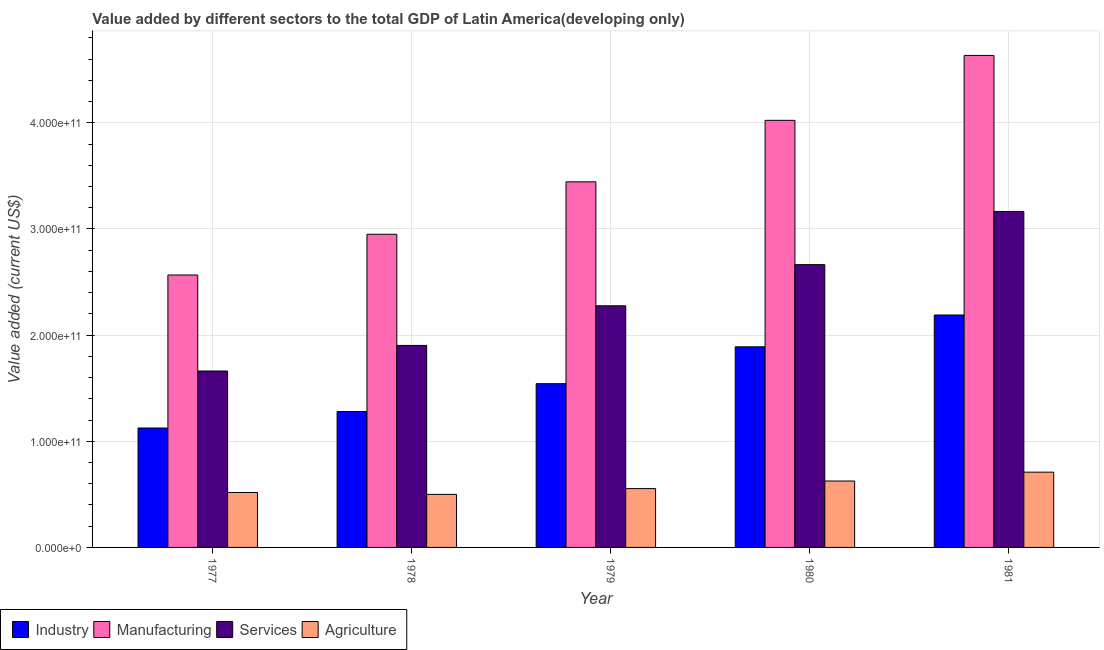How many groups of bars are there?
Give a very brief answer. 5. Are the number of bars per tick equal to the number of legend labels?
Provide a short and direct response. Yes. How many bars are there on the 2nd tick from the left?
Provide a short and direct response. 4. How many bars are there on the 5th tick from the right?
Your answer should be very brief. 4. What is the value added by agricultural sector in 1979?
Offer a terse response. 5.54e+1. Across all years, what is the maximum value added by manufacturing sector?
Keep it short and to the point. 4.63e+11. Across all years, what is the minimum value added by agricultural sector?
Your answer should be compact. 5.00e+1. In which year was the value added by services sector maximum?
Offer a very short reply. 1981. What is the total value added by agricultural sector in the graph?
Make the answer very short. 2.91e+11. What is the difference between the value added by manufacturing sector in 1977 and that in 1980?
Offer a terse response. -1.46e+11. What is the difference between the value added by services sector in 1979 and the value added by manufacturing sector in 1981?
Provide a succinct answer. -8.89e+1. What is the average value added by industrial sector per year?
Keep it short and to the point. 1.61e+11. What is the ratio of the value added by manufacturing sector in 1978 to that in 1979?
Your response must be concise. 0.86. What is the difference between the highest and the second highest value added by manufacturing sector?
Your response must be concise. 6.11e+1. What is the difference between the highest and the lowest value added by industrial sector?
Give a very brief answer. 1.06e+11. In how many years, is the value added by services sector greater than the average value added by services sector taken over all years?
Offer a terse response. 2. Is the sum of the value added by agricultural sector in 1977 and 1978 greater than the maximum value added by services sector across all years?
Make the answer very short. Yes. What does the 4th bar from the left in 1979 represents?
Your answer should be compact. Agriculture. What does the 4th bar from the right in 1979 represents?
Provide a succinct answer. Industry. Is it the case that in every year, the sum of the value added by industrial sector and value added by manufacturing sector is greater than the value added by services sector?
Your response must be concise. Yes. How many bars are there?
Your response must be concise. 20. What is the difference between two consecutive major ticks on the Y-axis?
Your answer should be compact. 1.00e+11. Are the values on the major ticks of Y-axis written in scientific E-notation?
Give a very brief answer. Yes. How many legend labels are there?
Your answer should be very brief. 4. How are the legend labels stacked?
Your answer should be compact. Horizontal. What is the title of the graph?
Ensure brevity in your answer.  Value added by different sectors to the total GDP of Latin America(developing only). What is the label or title of the X-axis?
Make the answer very short. Year. What is the label or title of the Y-axis?
Offer a very short reply. Value added (current US$). What is the Value added (current US$) of Industry in 1977?
Provide a short and direct response. 1.13e+11. What is the Value added (current US$) in Manufacturing in 1977?
Keep it short and to the point. 2.57e+11. What is the Value added (current US$) of Services in 1977?
Keep it short and to the point. 1.66e+11. What is the Value added (current US$) of Agriculture in 1977?
Provide a short and direct response. 5.17e+1. What is the Value added (current US$) of Industry in 1978?
Keep it short and to the point. 1.28e+11. What is the Value added (current US$) of Manufacturing in 1978?
Your answer should be very brief. 2.95e+11. What is the Value added (current US$) of Services in 1978?
Offer a terse response. 1.90e+11. What is the Value added (current US$) in Agriculture in 1978?
Offer a terse response. 5.00e+1. What is the Value added (current US$) of Industry in 1979?
Provide a succinct answer. 1.54e+11. What is the Value added (current US$) in Manufacturing in 1979?
Make the answer very short. 3.44e+11. What is the Value added (current US$) of Services in 1979?
Give a very brief answer. 2.28e+11. What is the Value added (current US$) in Agriculture in 1979?
Ensure brevity in your answer.  5.54e+1. What is the Value added (current US$) in Industry in 1980?
Your answer should be compact. 1.89e+11. What is the Value added (current US$) in Manufacturing in 1980?
Keep it short and to the point. 4.02e+11. What is the Value added (current US$) in Services in 1980?
Your answer should be compact. 2.66e+11. What is the Value added (current US$) in Agriculture in 1980?
Provide a succinct answer. 6.26e+1. What is the Value added (current US$) in Industry in 1981?
Offer a very short reply. 2.19e+11. What is the Value added (current US$) of Manufacturing in 1981?
Ensure brevity in your answer.  4.63e+11. What is the Value added (current US$) in Services in 1981?
Provide a succinct answer. 3.17e+11. What is the Value added (current US$) in Agriculture in 1981?
Provide a succinct answer. 7.09e+1. Across all years, what is the maximum Value added (current US$) of Industry?
Your response must be concise. 2.19e+11. Across all years, what is the maximum Value added (current US$) of Manufacturing?
Offer a very short reply. 4.63e+11. Across all years, what is the maximum Value added (current US$) in Services?
Ensure brevity in your answer.  3.17e+11. Across all years, what is the maximum Value added (current US$) in Agriculture?
Give a very brief answer. 7.09e+1. Across all years, what is the minimum Value added (current US$) of Industry?
Provide a short and direct response. 1.13e+11. Across all years, what is the minimum Value added (current US$) of Manufacturing?
Provide a short and direct response. 2.57e+11. Across all years, what is the minimum Value added (current US$) of Services?
Offer a very short reply. 1.66e+11. Across all years, what is the minimum Value added (current US$) in Agriculture?
Offer a very short reply. 5.00e+1. What is the total Value added (current US$) of Industry in the graph?
Your answer should be very brief. 8.03e+11. What is the total Value added (current US$) of Manufacturing in the graph?
Keep it short and to the point. 1.76e+12. What is the total Value added (current US$) of Services in the graph?
Keep it short and to the point. 1.17e+12. What is the total Value added (current US$) in Agriculture in the graph?
Give a very brief answer. 2.91e+11. What is the difference between the Value added (current US$) in Industry in 1977 and that in 1978?
Offer a very short reply. -1.55e+1. What is the difference between the Value added (current US$) in Manufacturing in 1977 and that in 1978?
Your answer should be very brief. -3.84e+1. What is the difference between the Value added (current US$) of Services in 1977 and that in 1978?
Make the answer very short. -2.41e+1. What is the difference between the Value added (current US$) in Agriculture in 1977 and that in 1978?
Ensure brevity in your answer.  1.76e+09. What is the difference between the Value added (current US$) of Industry in 1977 and that in 1979?
Your answer should be very brief. -4.18e+1. What is the difference between the Value added (current US$) of Manufacturing in 1977 and that in 1979?
Offer a terse response. -8.78e+1. What is the difference between the Value added (current US$) of Services in 1977 and that in 1979?
Make the answer very short. -6.14e+1. What is the difference between the Value added (current US$) of Agriculture in 1977 and that in 1979?
Ensure brevity in your answer.  -3.68e+09. What is the difference between the Value added (current US$) of Industry in 1977 and that in 1980?
Provide a succinct answer. -7.65e+1. What is the difference between the Value added (current US$) of Manufacturing in 1977 and that in 1980?
Provide a short and direct response. -1.46e+11. What is the difference between the Value added (current US$) in Services in 1977 and that in 1980?
Offer a terse response. -1.00e+11. What is the difference between the Value added (current US$) in Agriculture in 1977 and that in 1980?
Provide a succinct answer. -1.08e+1. What is the difference between the Value added (current US$) in Industry in 1977 and that in 1981?
Provide a succinct answer. -1.06e+11. What is the difference between the Value added (current US$) of Manufacturing in 1977 and that in 1981?
Provide a short and direct response. -2.07e+11. What is the difference between the Value added (current US$) in Services in 1977 and that in 1981?
Offer a very short reply. -1.50e+11. What is the difference between the Value added (current US$) of Agriculture in 1977 and that in 1981?
Provide a short and direct response. -1.92e+1. What is the difference between the Value added (current US$) of Industry in 1978 and that in 1979?
Ensure brevity in your answer.  -2.62e+1. What is the difference between the Value added (current US$) in Manufacturing in 1978 and that in 1979?
Give a very brief answer. -4.94e+1. What is the difference between the Value added (current US$) of Services in 1978 and that in 1979?
Give a very brief answer. -3.73e+1. What is the difference between the Value added (current US$) of Agriculture in 1978 and that in 1979?
Make the answer very short. -5.45e+09. What is the difference between the Value added (current US$) in Industry in 1978 and that in 1980?
Keep it short and to the point. -6.10e+1. What is the difference between the Value added (current US$) in Manufacturing in 1978 and that in 1980?
Your response must be concise. -1.07e+11. What is the difference between the Value added (current US$) in Services in 1978 and that in 1980?
Your answer should be very brief. -7.61e+1. What is the difference between the Value added (current US$) of Agriculture in 1978 and that in 1980?
Ensure brevity in your answer.  -1.26e+1. What is the difference between the Value added (current US$) in Industry in 1978 and that in 1981?
Ensure brevity in your answer.  -9.09e+1. What is the difference between the Value added (current US$) of Manufacturing in 1978 and that in 1981?
Provide a succinct answer. -1.68e+11. What is the difference between the Value added (current US$) in Services in 1978 and that in 1981?
Ensure brevity in your answer.  -1.26e+11. What is the difference between the Value added (current US$) of Agriculture in 1978 and that in 1981?
Offer a very short reply. -2.09e+1. What is the difference between the Value added (current US$) of Industry in 1979 and that in 1980?
Offer a terse response. -3.47e+1. What is the difference between the Value added (current US$) of Manufacturing in 1979 and that in 1980?
Offer a terse response. -5.79e+1. What is the difference between the Value added (current US$) in Services in 1979 and that in 1980?
Your answer should be very brief. -3.88e+1. What is the difference between the Value added (current US$) in Agriculture in 1979 and that in 1980?
Offer a very short reply. -7.13e+09. What is the difference between the Value added (current US$) in Industry in 1979 and that in 1981?
Offer a terse response. -6.47e+1. What is the difference between the Value added (current US$) in Manufacturing in 1979 and that in 1981?
Provide a succinct answer. -1.19e+11. What is the difference between the Value added (current US$) in Services in 1979 and that in 1981?
Provide a succinct answer. -8.89e+1. What is the difference between the Value added (current US$) in Agriculture in 1979 and that in 1981?
Keep it short and to the point. -1.55e+1. What is the difference between the Value added (current US$) of Industry in 1980 and that in 1981?
Provide a succinct answer. -3.00e+1. What is the difference between the Value added (current US$) in Manufacturing in 1980 and that in 1981?
Make the answer very short. -6.11e+1. What is the difference between the Value added (current US$) of Services in 1980 and that in 1981?
Provide a short and direct response. -5.01e+1. What is the difference between the Value added (current US$) of Agriculture in 1980 and that in 1981?
Your answer should be compact. -8.35e+09. What is the difference between the Value added (current US$) of Industry in 1977 and the Value added (current US$) of Manufacturing in 1978?
Keep it short and to the point. -1.83e+11. What is the difference between the Value added (current US$) of Industry in 1977 and the Value added (current US$) of Services in 1978?
Your answer should be compact. -7.78e+1. What is the difference between the Value added (current US$) in Industry in 1977 and the Value added (current US$) in Agriculture in 1978?
Provide a succinct answer. 6.25e+1. What is the difference between the Value added (current US$) in Manufacturing in 1977 and the Value added (current US$) in Services in 1978?
Provide a short and direct response. 6.63e+1. What is the difference between the Value added (current US$) of Manufacturing in 1977 and the Value added (current US$) of Agriculture in 1978?
Offer a terse response. 2.07e+11. What is the difference between the Value added (current US$) in Services in 1977 and the Value added (current US$) in Agriculture in 1978?
Make the answer very short. 1.16e+11. What is the difference between the Value added (current US$) in Industry in 1977 and the Value added (current US$) in Manufacturing in 1979?
Your answer should be very brief. -2.32e+11. What is the difference between the Value added (current US$) in Industry in 1977 and the Value added (current US$) in Services in 1979?
Offer a very short reply. -1.15e+11. What is the difference between the Value added (current US$) in Industry in 1977 and the Value added (current US$) in Agriculture in 1979?
Make the answer very short. 5.71e+1. What is the difference between the Value added (current US$) in Manufacturing in 1977 and the Value added (current US$) in Services in 1979?
Give a very brief answer. 2.90e+1. What is the difference between the Value added (current US$) in Manufacturing in 1977 and the Value added (current US$) in Agriculture in 1979?
Ensure brevity in your answer.  2.01e+11. What is the difference between the Value added (current US$) in Services in 1977 and the Value added (current US$) in Agriculture in 1979?
Offer a very short reply. 1.11e+11. What is the difference between the Value added (current US$) of Industry in 1977 and the Value added (current US$) of Manufacturing in 1980?
Provide a succinct answer. -2.90e+11. What is the difference between the Value added (current US$) of Industry in 1977 and the Value added (current US$) of Services in 1980?
Your response must be concise. -1.54e+11. What is the difference between the Value added (current US$) of Industry in 1977 and the Value added (current US$) of Agriculture in 1980?
Offer a very short reply. 4.99e+1. What is the difference between the Value added (current US$) in Manufacturing in 1977 and the Value added (current US$) in Services in 1980?
Your response must be concise. -9.77e+09. What is the difference between the Value added (current US$) in Manufacturing in 1977 and the Value added (current US$) in Agriculture in 1980?
Give a very brief answer. 1.94e+11. What is the difference between the Value added (current US$) in Services in 1977 and the Value added (current US$) in Agriculture in 1980?
Keep it short and to the point. 1.04e+11. What is the difference between the Value added (current US$) in Industry in 1977 and the Value added (current US$) in Manufacturing in 1981?
Ensure brevity in your answer.  -3.51e+11. What is the difference between the Value added (current US$) in Industry in 1977 and the Value added (current US$) in Services in 1981?
Your response must be concise. -2.04e+11. What is the difference between the Value added (current US$) of Industry in 1977 and the Value added (current US$) of Agriculture in 1981?
Offer a very short reply. 4.16e+1. What is the difference between the Value added (current US$) in Manufacturing in 1977 and the Value added (current US$) in Services in 1981?
Keep it short and to the point. -5.99e+1. What is the difference between the Value added (current US$) in Manufacturing in 1977 and the Value added (current US$) in Agriculture in 1981?
Offer a very short reply. 1.86e+11. What is the difference between the Value added (current US$) of Services in 1977 and the Value added (current US$) of Agriculture in 1981?
Provide a short and direct response. 9.53e+1. What is the difference between the Value added (current US$) of Industry in 1978 and the Value added (current US$) of Manufacturing in 1979?
Provide a succinct answer. -2.16e+11. What is the difference between the Value added (current US$) of Industry in 1978 and the Value added (current US$) of Services in 1979?
Your answer should be compact. -9.96e+1. What is the difference between the Value added (current US$) of Industry in 1978 and the Value added (current US$) of Agriculture in 1979?
Offer a very short reply. 7.26e+1. What is the difference between the Value added (current US$) of Manufacturing in 1978 and the Value added (current US$) of Services in 1979?
Provide a short and direct response. 6.74e+1. What is the difference between the Value added (current US$) of Manufacturing in 1978 and the Value added (current US$) of Agriculture in 1979?
Offer a terse response. 2.40e+11. What is the difference between the Value added (current US$) in Services in 1978 and the Value added (current US$) in Agriculture in 1979?
Provide a succinct answer. 1.35e+11. What is the difference between the Value added (current US$) of Industry in 1978 and the Value added (current US$) of Manufacturing in 1980?
Make the answer very short. -2.74e+11. What is the difference between the Value added (current US$) in Industry in 1978 and the Value added (current US$) in Services in 1980?
Ensure brevity in your answer.  -1.38e+11. What is the difference between the Value added (current US$) in Industry in 1978 and the Value added (current US$) in Agriculture in 1980?
Give a very brief answer. 6.55e+1. What is the difference between the Value added (current US$) in Manufacturing in 1978 and the Value added (current US$) in Services in 1980?
Provide a short and direct response. 2.86e+1. What is the difference between the Value added (current US$) of Manufacturing in 1978 and the Value added (current US$) of Agriculture in 1980?
Ensure brevity in your answer.  2.32e+11. What is the difference between the Value added (current US$) in Services in 1978 and the Value added (current US$) in Agriculture in 1980?
Give a very brief answer. 1.28e+11. What is the difference between the Value added (current US$) in Industry in 1978 and the Value added (current US$) in Manufacturing in 1981?
Offer a very short reply. -3.35e+11. What is the difference between the Value added (current US$) of Industry in 1978 and the Value added (current US$) of Services in 1981?
Make the answer very short. -1.89e+11. What is the difference between the Value added (current US$) in Industry in 1978 and the Value added (current US$) in Agriculture in 1981?
Keep it short and to the point. 5.71e+1. What is the difference between the Value added (current US$) in Manufacturing in 1978 and the Value added (current US$) in Services in 1981?
Your answer should be compact. -2.15e+1. What is the difference between the Value added (current US$) in Manufacturing in 1978 and the Value added (current US$) in Agriculture in 1981?
Your response must be concise. 2.24e+11. What is the difference between the Value added (current US$) in Services in 1978 and the Value added (current US$) in Agriculture in 1981?
Provide a short and direct response. 1.19e+11. What is the difference between the Value added (current US$) in Industry in 1979 and the Value added (current US$) in Manufacturing in 1980?
Give a very brief answer. -2.48e+11. What is the difference between the Value added (current US$) of Industry in 1979 and the Value added (current US$) of Services in 1980?
Offer a very short reply. -1.12e+11. What is the difference between the Value added (current US$) in Industry in 1979 and the Value added (current US$) in Agriculture in 1980?
Keep it short and to the point. 9.17e+1. What is the difference between the Value added (current US$) in Manufacturing in 1979 and the Value added (current US$) in Services in 1980?
Ensure brevity in your answer.  7.80e+1. What is the difference between the Value added (current US$) of Manufacturing in 1979 and the Value added (current US$) of Agriculture in 1980?
Offer a very short reply. 2.82e+11. What is the difference between the Value added (current US$) in Services in 1979 and the Value added (current US$) in Agriculture in 1980?
Ensure brevity in your answer.  1.65e+11. What is the difference between the Value added (current US$) of Industry in 1979 and the Value added (current US$) of Manufacturing in 1981?
Offer a terse response. -3.09e+11. What is the difference between the Value added (current US$) in Industry in 1979 and the Value added (current US$) in Services in 1981?
Your response must be concise. -1.62e+11. What is the difference between the Value added (current US$) in Industry in 1979 and the Value added (current US$) in Agriculture in 1981?
Your answer should be compact. 8.34e+1. What is the difference between the Value added (current US$) in Manufacturing in 1979 and the Value added (current US$) in Services in 1981?
Provide a short and direct response. 2.79e+1. What is the difference between the Value added (current US$) in Manufacturing in 1979 and the Value added (current US$) in Agriculture in 1981?
Give a very brief answer. 2.74e+11. What is the difference between the Value added (current US$) in Services in 1979 and the Value added (current US$) in Agriculture in 1981?
Provide a succinct answer. 1.57e+11. What is the difference between the Value added (current US$) of Industry in 1980 and the Value added (current US$) of Manufacturing in 1981?
Make the answer very short. -2.75e+11. What is the difference between the Value added (current US$) of Industry in 1980 and the Value added (current US$) of Services in 1981?
Your answer should be compact. -1.28e+11. What is the difference between the Value added (current US$) of Industry in 1980 and the Value added (current US$) of Agriculture in 1981?
Make the answer very short. 1.18e+11. What is the difference between the Value added (current US$) of Manufacturing in 1980 and the Value added (current US$) of Services in 1981?
Ensure brevity in your answer.  8.58e+1. What is the difference between the Value added (current US$) of Manufacturing in 1980 and the Value added (current US$) of Agriculture in 1981?
Give a very brief answer. 3.31e+11. What is the difference between the Value added (current US$) in Services in 1980 and the Value added (current US$) in Agriculture in 1981?
Provide a short and direct response. 1.96e+11. What is the average Value added (current US$) in Industry per year?
Your answer should be very brief. 1.61e+11. What is the average Value added (current US$) in Manufacturing per year?
Offer a terse response. 3.52e+11. What is the average Value added (current US$) in Services per year?
Your response must be concise. 2.33e+11. What is the average Value added (current US$) in Agriculture per year?
Give a very brief answer. 5.81e+1. In the year 1977, what is the difference between the Value added (current US$) of Industry and Value added (current US$) of Manufacturing?
Give a very brief answer. -1.44e+11. In the year 1977, what is the difference between the Value added (current US$) in Industry and Value added (current US$) in Services?
Provide a succinct answer. -5.37e+1. In the year 1977, what is the difference between the Value added (current US$) in Industry and Value added (current US$) in Agriculture?
Your response must be concise. 6.08e+1. In the year 1977, what is the difference between the Value added (current US$) in Manufacturing and Value added (current US$) in Services?
Provide a short and direct response. 9.04e+1. In the year 1977, what is the difference between the Value added (current US$) of Manufacturing and Value added (current US$) of Agriculture?
Give a very brief answer. 2.05e+11. In the year 1977, what is the difference between the Value added (current US$) of Services and Value added (current US$) of Agriculture?
Your response must be concise. 1.14e+11. In the year 1978, what is the difference between the Value added (current US$) in Industry and Value added (current US$) in Manufacturing?
Your response must be concise. -1.67e+11. In the year 1978, what is the difference between the Value added (current US$) of Industry and Value added (current US$) of Services?
Keep it short and to the point. -6.23e+1. In the year 1978, what is the difference between the Value added (current US$) of Industry and Value added (current US$) of Agriculture?
Ensure brevity in your answer.  7.80e+1. In the year 1978, what is the difference between the Value added (current US$) of Manufacturing and Value added (current US$) of Services?
Keep it short and to the point. 1.05e+11. In the year 1978, what is the difference between the Value added (current US$) of Manufacturing and Value added (current US$) of Agriculture?
Your answer should be compact. 2.45e+11. In the year 1978, what is the difference between the Value added (current US$) of Services and Value added (current US$) of Agriculture?
Provide a succinct answer. 1.40e+11. In the year 1979, what is the difference between the Value added (current US$) of Industry and Value added (current US$) of Manufacturing?
Offer a terse response. -1.90e+11. In the year 1979, what is the difference between the Value added (current US$) in Industry and Value added (current US$) in Services?
Your answer should be compact. -7.34e+1. In the year 1979, what is the difference between the Value added (current US$) of Industry and Value added (current US$) of Agriculture?
Your answer should be compact. 9.88e+1. In the year 1979, what is the difference between the Value added (current US$) of Manufacturing and Value added (current US$) of Services?
Provide a succinct answer. 1.17e+11. In the year 1979, what is the difference between the Value added (current US$) of Manufacturing and Value added (current US$) of Agriculture?
Your answer should be very brief. 2.89e+11. In the year 1979, what is the difference between the Value added (current US$) in Services and Value added (current US$) in Agriculture?
Your answer should be very brief. 1.72e+11. In the year 1980, what is the difference between the Value added (current US$) in Industry and Value added (current US$) in Manufacturing?
Your answer should be very brief. -2.13e+11. In the year 1980, what is the difference between the Value added (current US$) of Industry and Value added (current US$) of Services?
Provide a short and direct response. -7.74e+1. In the year 1980, what is the difference between the Value added (current US$) in Industry and Value added (current US$) in Agriculture?
Provide a short and direct response. 1.26e+11. In the year 1980, what is the difference between the Value added (current US$) of Manufacturing and Value added (current US$) of Services?
Give a very brief answer. 1.36e+11. In the year 1980, what is the difference between the Value added (current US$) in Manufacturing and Value added (current US$) in Agriculture?
Make the answer very short. 3.40e+11. In the year 1980, what is the difference between the Value added (current US$) of Services and Value added (current US$) of Agriculture?
Keep it short and to the point. 2.04e+11. In the year 1981, what is the difference between the Value added (current US$) in Industry and Value added (current US$) in Manufacturing?
Keep it short and to the point. -2.45e+11. In the year 1981, what is the difference between the Value added (current US$) in Industry and Value added (current US$) in Services?
Keep it short and to the point. -9.76e+1. In the year 1981, what is the difference between the Value added (current US$) in Industry and Value added (current US$) in Agriculture?
Offer a very short reply. 1.48e+11. In the year 1981, what is the difference between the Value added (current US$) of Manufacturing and Value added (current US$) of Services?
Your response must be concise. 1.47e+11. In the year 1981, what is the difference between the Value added (current US$) of Manufacturing and Value added (current US$) of Agriculture?
Provide a short and direct response. 3.93e+11. In the year 1981, what is the difference between the Value added (current US$) in Services and Value added (current US$) in Agriculture?
Your response must be concise. 2.46e+11. What is the ratio of the Value added (current US$) of Industry in 1977 to that in 1978?
Your answer should be compact. 0.88. What is the ratio of the Value added (current US$) of Manufacturing in 1977 to that in 1978?
Ensure brevity in your answer.  0.87. What is the ratio of the Value added (current US$) in Services in 1977 to that in 1978?
Give a very brief answer. 0.87. What is the ratio of the Value added (current US$) of Agriculture in 1977 to that in 1978?
Ensure brevity in your answer.  1.04. What is the ratio of the Value added (current US$) in Industry in 1977 to that in 1979?
Keep it short and to the point. 0.73. What is the ratio of the Value added (current US$) of Manufacturing in 1977 to that in 1979?
Your response must be concise. 0.75. What is the ratio of the Value added (current US$) of Services in 1977 to that in 1979?
Provide a short and direct response. 0.73. What is the ratio of the Value added (current US$) of Agriculture in 1977 to that in 1979?
Make the answer very short. 0.93. What is the ratio of the Value added (current US$) in Industry in 1977 to that in 1980?
Provide a short and direct response. 0.6. What is the ratio of the Value added (current US$) in Manufacturing in 1977 to that in 1980?
Offer a terse response. 0.64. What is the ratio of the Value added (current US$) of Services in 1977 to that in 1980?
Offer a very short reply. 0.62. What is the ratio of the Value added (current US$) of Agriculture in 1977 to that in 1980?
Give a very brief answer. 0.83. What is the ratio of the Value added (current US$) in Industry in 1977 to that in 1981?
Provide a short and direct response. 0.51. What is the ratio of the Value added (current US$) of Manufacturing in 1977 to that in 1981?
Give a very brief answer. 0.55. What is the ratio of the Value added (current US$) of Services in 1977 to that in 1981?
Offer a very short reply. 0.53. What is the ratio of the Value added (current US$) in Agriculture in 1977 to that in 1981?
Provide a short and direct response. 0.73. What is the ratio of the Value added (current US$) of Industry in 1978 to that in 1979?
Your answer should be very brief. 0.83. What is the ratio of the Value added (current US$) in Manufacturing in 1978 to that in 1979?
Provide a short and direct response. 0.86. What is the ratio of the Value added (current US$) of Services in 1978 to that in 1979?
Your answer should be very brief. 0.84. What is the ratio of the Value added (current US$) in Agriculture in 1978 to that in 1979?
Keep it short and to the point. 0.9. What is the ratio of the Value added (current US$) of Industry in 1978 to that in 1980?
Provide a succinct answer. 0.68. What is the ratio of the Value added (current US$) in Manufacturing in 1978 to that in 1980?
Offer a very short reply. 0.73. What is the ratio of the Value added (current US$) of Agriculture in 1978 to that in 1980?
Keep it short and to the point. 0.8. What is the ratio of the Value added (current US$) in Industry in 1978 to that in 1981?
Provide a short and direct response. 0.58. What is the ratio of the Value added (current US$) of Manufacturing in 1978 to that in 1981?
Provide a short and direct response. 0.64. What is the ratio of the Value added (current US$) of Services in 1978 to that in 1981?
Your response must be concise. 0.6. What is the ratio of the Value added (current US$) of Agriculture in 1978 to that in 1981?
Your answer should be very brief. 0.7. What is the ratio of the Value added (current US$) in Industry in 1979 to that in 1980?
Your answer should be compact. 0.82. What is the ratio of the Value added (current US$) of Manufacturing in 1979 to that in 1980?
Ensure brevity in your answer.  0.86. What is the ratio of the Value added (current US$) in Services in 1979 to that in 1980?
Offer a very short reply. 0.85. What is the ratio of the Value added (current US$) of Agriculture in 1979 to that in 1980?
Provide a succinct answer. 0.89. What is the ratio of the Value added (current US$) in Industry in 1979 to that in 1981?
Offer a very short reply. 0.7. What is the ratio of the Value added (current US$) in Manufacturing in 1979 to that in 1981?
Provide a short and direct response. 0.74. What is the ratio of the Value added (current US$) in Services in 1979 to that in 1981?
Offer a very short reply. 0.72. What is the ratio of the Value added (current US$) in Agriculture in 1979 to that in 1981?
Your response must be concise. 0.78. What is the ratio of the Value added (current US$) of Industry in 1980 to that in 1981?
Your response must be concise. 0.86. What is the ratio of the Value added (current US$) of Manufacturing in 1980 to that in 1981?
Give a very brief answer. 0.87. What is the ratio of the Value added (current US$) of Services in 1980 to that in 1981?
Offer a terse response. 0.84. What is the ratio of the Value added (current US$) in Agriculture in 1980 to that in 1981?
Make the answer very short. 0.88. What is the difference between the highest and the second highest Value added (current US$) of Industry?
Keep it short and to the point. 3.00e+1. What is the difference between the highest and the second highest Value added (current US$) in Manufacturing?
Offer a terse response. 6.11e+1. What is the difference between the highest and the second highest Value added (current US$) in Services?
Keep it short and to the point. 5.01e+1. What is the difference between the highest and the second highest Value added (current US$) of Agriculture?
Keep it short and to the point. 8.35e+09. What is the difference between the highest and the lowest Value added (current US$) in Industry?
Offer a terse response. 1.06e+11. What is the difference between the highest and the lowest Value added (current US$) of Manufacturing?
Your response must be concise. 2.07e+11. What is the difference between the highest and the lowest Value added (current US$) in Services?
Your answer should be compact. 1.50e+11. What is the difference between the highest and the lowest Value added (current US$) of Agriculture?
Your response must be concise. 2.09e+1. 